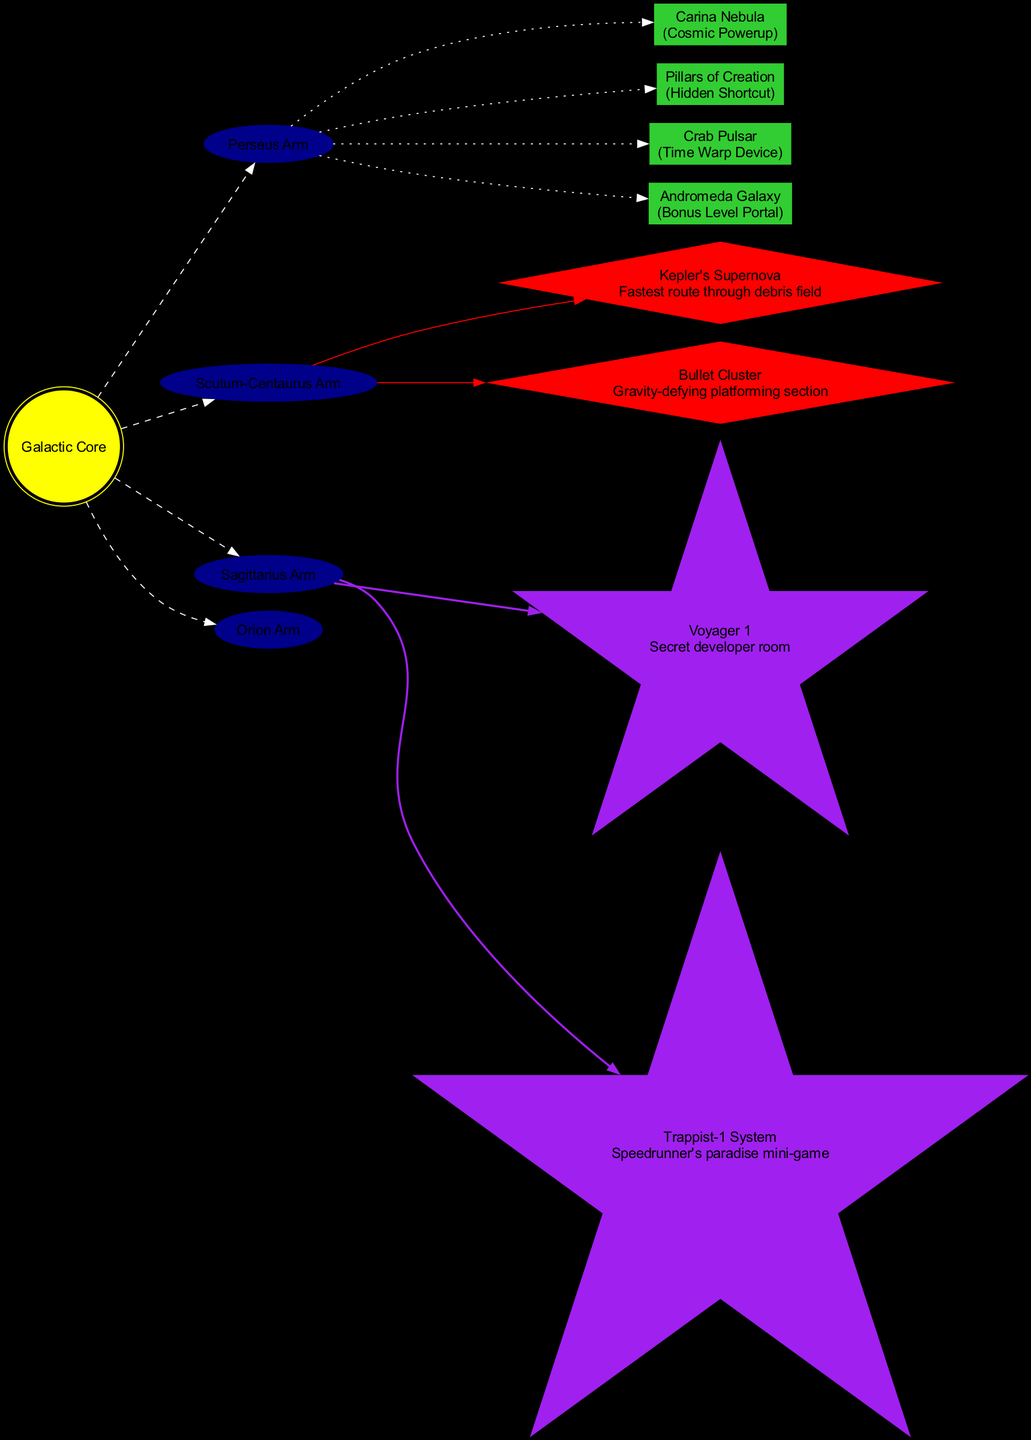What is the center of the Milky Way represented in the diagram? The diagram labels the center of the Milky Way as "Galactic Core." This can be observed as it is a prominent node that is highlighted.
Answer: Galactic Core How many galaxy arms are shown in the diagram? The diagram lists four arms: Perseus Arm, Scutum-Centaurus Arm, Sagittarius Arm, and Orion Arm. Counting these provides the answer.
Answer: 4 What collectible type is found in the Carina Nebula? The Carina Nebula is denoted as a location in the diagram, and it is specified to be a "Cosmic Powerup." This can be seen directly next to the collectible's name.
Answer: Cosmic Powerup Which speedrun challenge connects to the Scutum-Centaurus Arm? The Bullet Cluster is represented as a speedrun challenge and is linked to the Scutum-Centaurus Arm node in the diagram. This connection is indicated through the edge.
Answer: Bullet Cluster What is the description of the developer easter egg Voyager 1? The diagram states that Voyager 1 leads to a "Secret developer room." This description is below the name in the diagram and can be directly referenced.
Answer: Secret developer room Which collectible is identified as a Hidden Shortcut? The Pillars of Creation is classified under collectibles and identified specifically as a "Hidden Shortcut" in the diagram, making it easily identifiable for this detail.
Answer: Pillars of Creation How does the Crab Pulsar relate to speedrun challenges? The Crab Pulsar is not directly linked to any speedrun challenge, which can be inferred by checking the connection nodes; it is rather a distinct collectible location.
Answer: None What color represents speedrun challenges in this diagram? The diamond-shaped nodes representing speedrun challenges are colored red, as specified in the diagram's node attribute settings.
Answer: Red Which arm is directly connected to the Andromeda Galaxy? The Andromeda Galaxy collectible connects to the Perseus Arm in the diagram, as illustrated by the dotted line edge leading to it.
Answer: Perseus Arm 